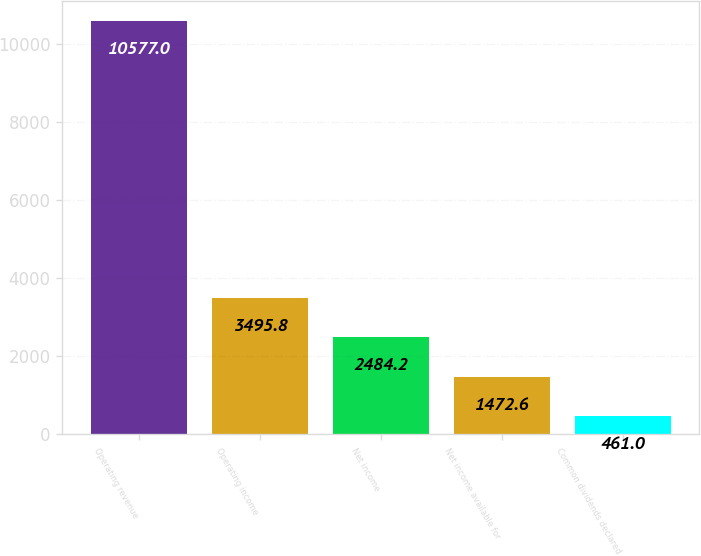Convert chart. <chart><loc_0><loc_0><loc_500><loc_500><bar_chart><fcel>Operating revenue<fcel>Operating income<fcel>Net income<fcel>Net income available for<fcel>Common dividends declared<nl><fcel>10577<fcel>3495.8<fcel>2484.2<fcel>1472.6<fcel>461<nl></chart> 